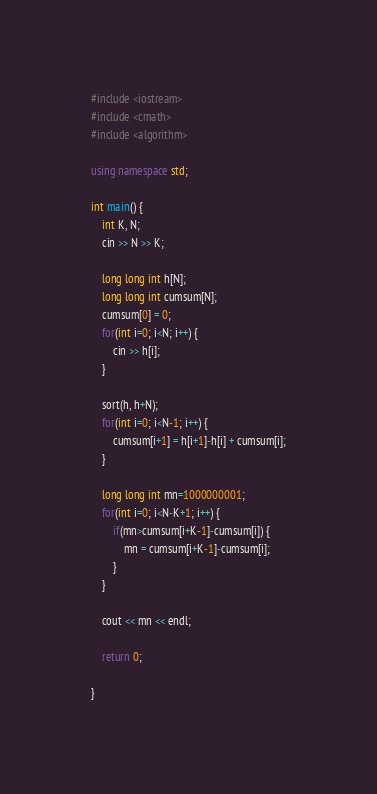<code> <loc_0><loc_0><loc_500><loc_500><_C++_>#include <iostream>
#include <cmath>
#include <algorithm>

using namespace std;

int main() {
    int K, N;
    cin >> N >> K;
    
    long long int h[N];
    long long int cumsum[N];
    cumsum[0] = 0;
    for(int i=0; i<N; i++) {
        cin >> h[i];
    }

    sort(h, h+N);
    for(int i=0; i<N-1; i++) {
        cumsum[i+1] = h[i+1]-h[i] + cumsum[i];
    }
    
    long long int mn=1000000001;
    for(int i=0; i<N-K+1; i++) {
        if(mn>cumsum[i+K-1]-cumsum[i]) {
            mn = cumsum[i+K-1]-cumsum[i];
        }
    }
    
    cout << mn << endl;

    return 0;
    
}</code> 